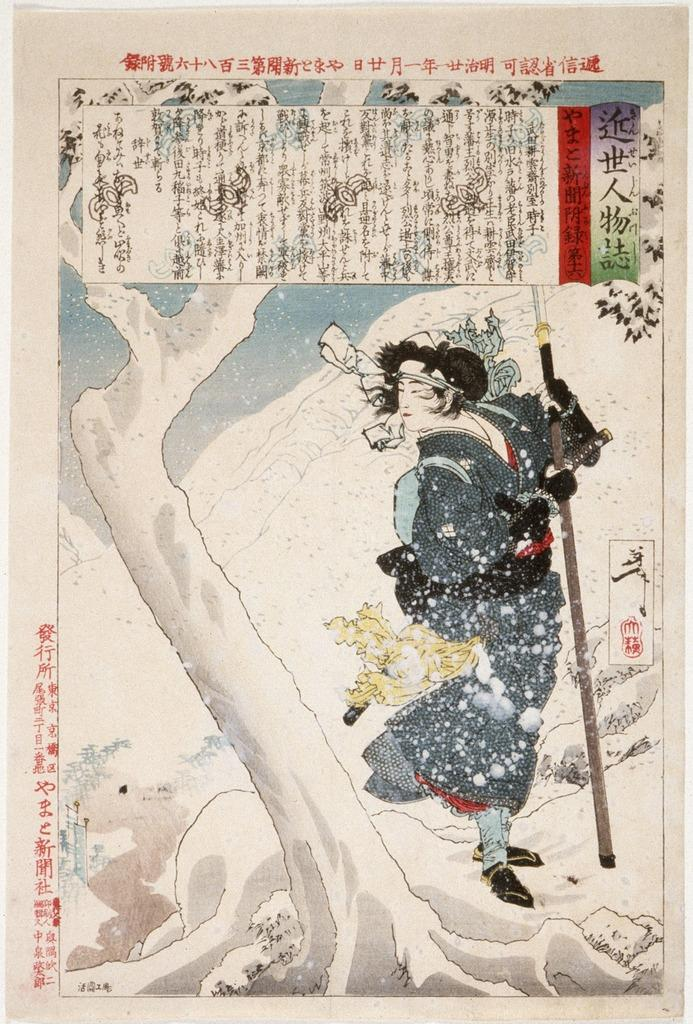What is featured on the poster in the image? The poster contains a tree and a woman holding a stick. Can you describe the woman holding the stick in the poster? The woman is holding a stick in the poster. What else can be seen on the poster besides the tree and the woman holding a stick? There is no additional information provided about the poster. What type of boot is the woman wearing in the image? There is no woman wearing a boot in the image; the woman in the poster is holding a stick, not wearing any footwear. 